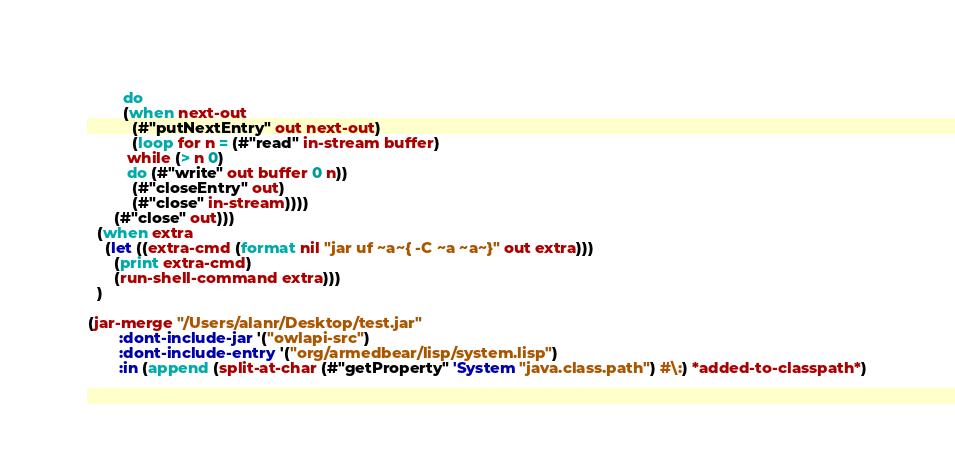<code> <loc_0><loc_0><loc_500><loc_500><_Lisp_>	    do
	    (when next-out
	      (#"putNextEntry" out next-out)
	      (loop for n = (#"read" in-stream buffer)
		 while (> n 0)
		 do (#"write" out buffer 0 n))
	      (#"closeEntry" out)
	      (#"close" in-stream))))
      (#"close" out)))
  (when extra
    (let ((extra-cmd (format nil "jar uf ~a~{ -C ~a ~a~}" out extra)))
      (print extra-cmd)
      (run-shell-command extra)))
  )

(jar-merge "/Users/alanr/Desktop/test.jar"
       :dont-include-jar '("owlapi-src")
       :dont-include-entry '("org/armedbear/lisp/system.lisp")
       :in (append (split-at-char (#"getProperty" 'System "java.class.path") #\:) *added-to-classpath*)</code> 